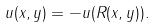Convert formula to latex. <formula><loc_0><loc_0><loc_500><loc_500>u ( x , y ) = - u ( R ( x , y ) ) .</formula> 